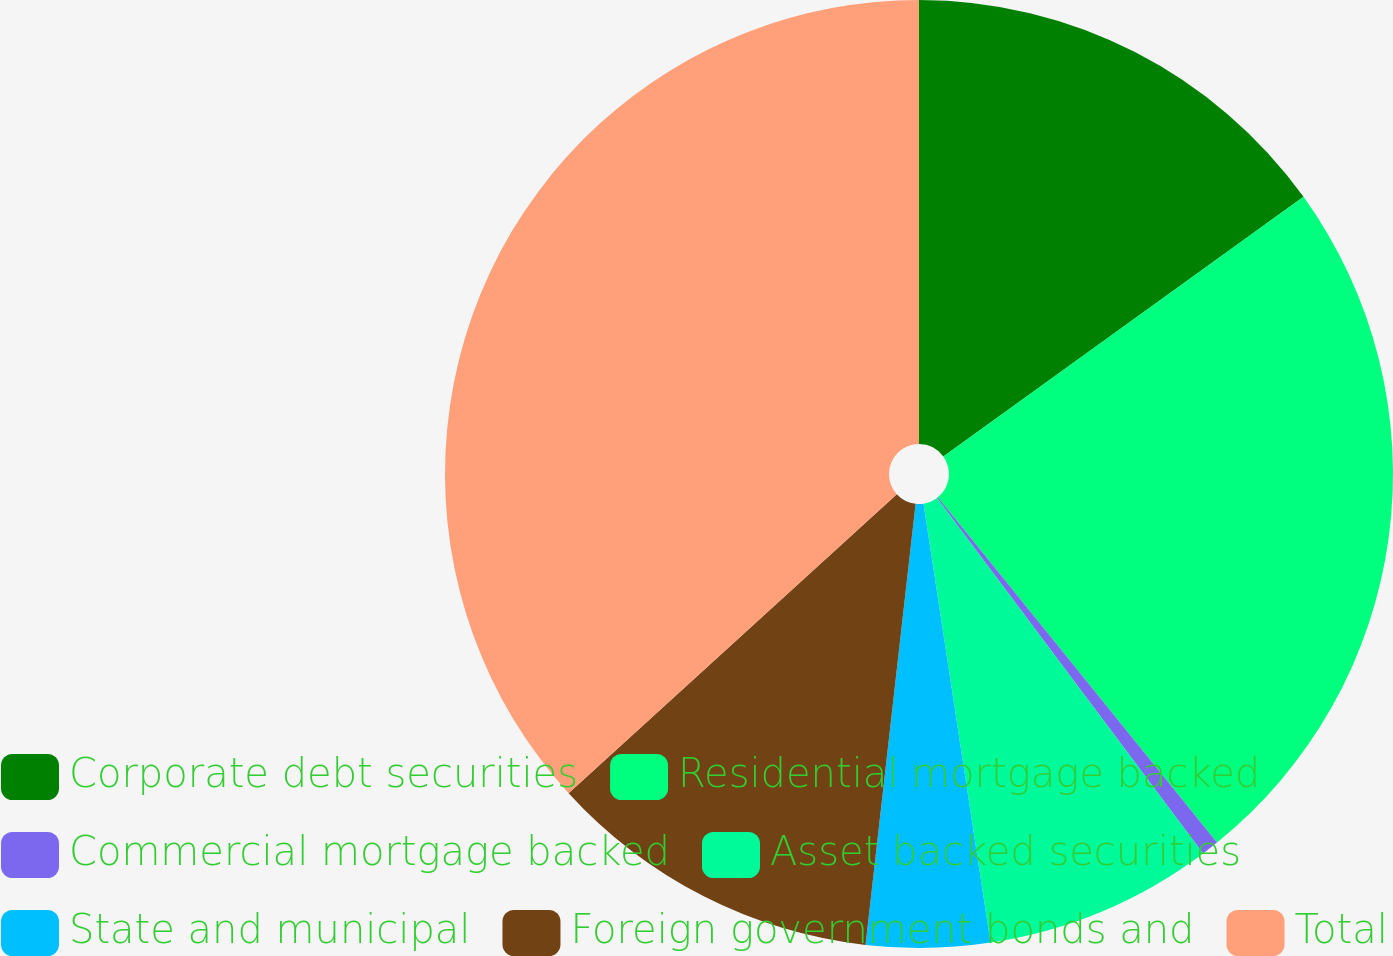<chart> <loc_0><loc_0><loc_500><loc_500><pie_chart><fcel>Corporate debt securities<fcel>Residential mortgage backed<fcel>Commercial mortgage backed<fcel>Asset backed securities<fcel>State and municipal<fcel>Foreign government bonds and<fcel>Total<nl><fcel>15.06%<fcel>24.12%<fcel>0.59%<fcel>7.82%<fcel>4.21%<fcel>11.44%<fcel>36.76%<nl></chart> 